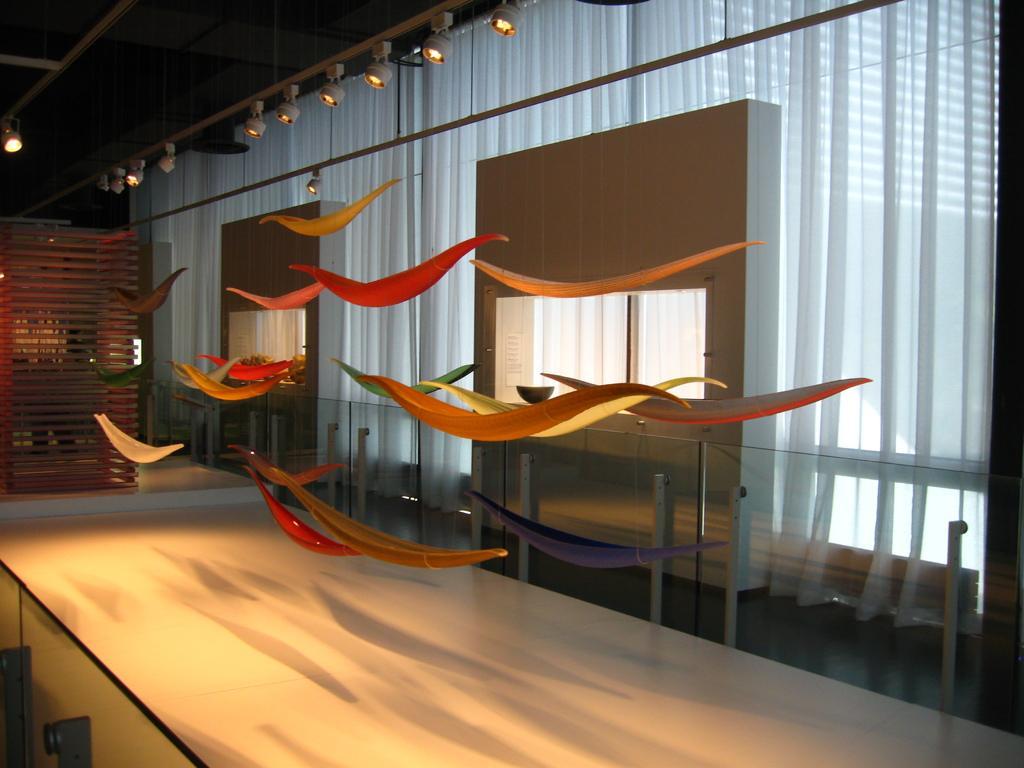In one or two sentences, can you explain what this image depicts? In this image we can see the inside of a house. There are few objects are hanged to the roof. There is a glass barrier in the image. There is a curtain in the image. There is a wooden object at the left side of the image. There are many lights in the image. 